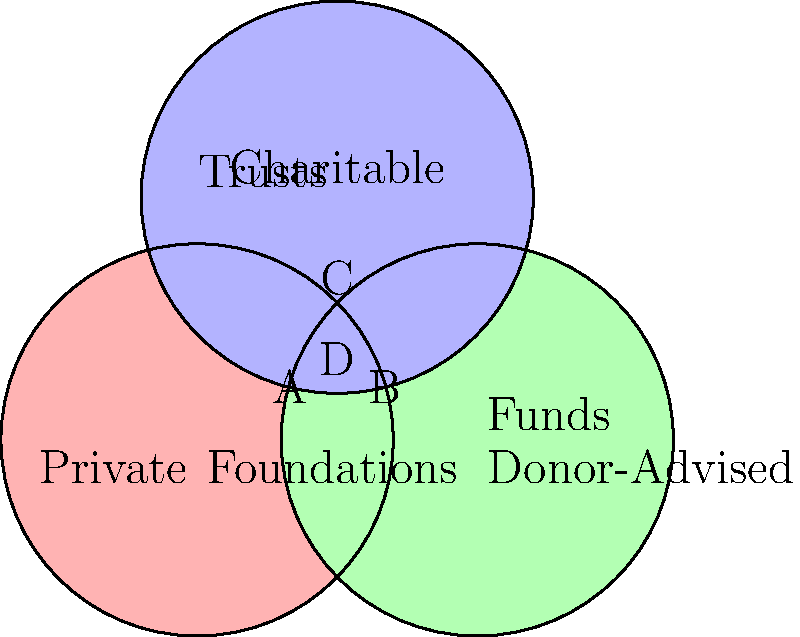Based on the Venn diagram showing the overlap between various charitable giving strategies and trust structures, which area represents the intersection of all three strategies: Private Foundations, Donor-Advised Funds, and Charitable Trusts? To answer this question, we need to analyze the Venn diagram and understand the relationships between the three charitable giving strategies:

1. The red circle represents Private Foundations.
2. The green circle represents Donor-Advised Funds.
3. The blue circle represents Charitable Trusts.

The areas of overlap in the diagram represent the following:

A: Intersection of Private Foundations and Charitable Trusts only
B: Intersection of Donor-Advised Funds and Charitable Trusts only
C: Intersection of Private Foundations and Donor-Advised Funds only
D: Intersection of all three strategies - Private Foundations, Donor-Advised Funds, and Charitable Trusts

The question asks for the area that represents the intersection of all three strategies. This is clearly represented by area D in the center of the diagram, where all three circles overlap.
Answer: D 